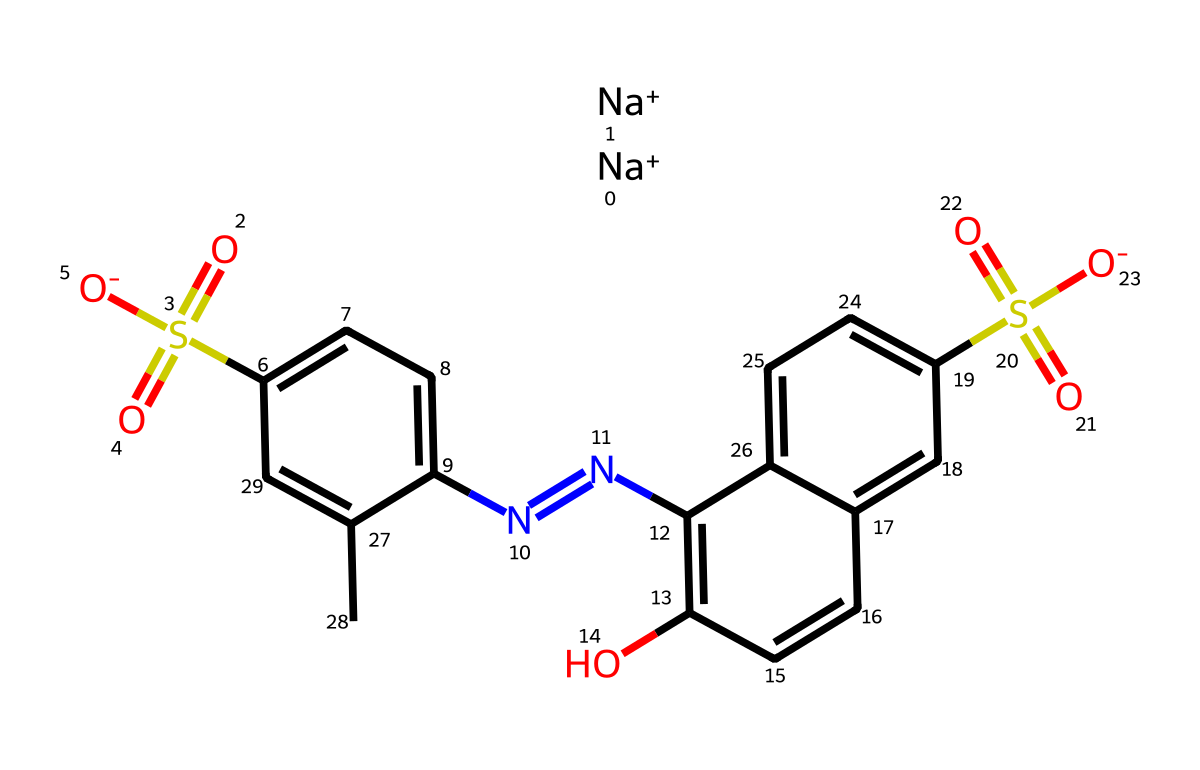What is the common name of this chemical? The SMILES representation corresponds to Allura Red, commonly known as Red Dye #40, which is a widely used food coloring.
Answer: Red Dye #40 How many sodium ions are present in this structure? The SMILES shows two instances of "[Na+]", indicating the presence of two sodium ions associated with the molecule.
Answer: 2 What functional group indicates it is a sulfonic acid derivative? The presence of "S(=O)(=O)" in the structure suggests a sulfonate functional group, which confirms that it is a sulfonic acid derivative.
Answer: sulfonate Which part of the compound is responsible for its color? The azo group "N=N" in the structure is known to contribute to the color properties of dyes, especially in food coloring like Red Dye #40.
Answer: azo group What type of chemical interaction might be involved due to the sulfonate group? The sulfonate group can participate in ionic interactions, which are crucial in solubility and stability in aqueous environments, typical for food additives.
Answer: ionic interactions What is the total number of aromatic rings in this structure? Analyzing the structure reveals three distinct aromatic rings, contributing to the stability and color properties of the coloring agent.
Answer: 3 What is the charge state of the molecule in its typical food additive form? The presence of two sodium ions compensates for the negative charges from the sulfonate groups, making the net charge of the compound neutral in its typical usage form.
Answer: neutral 